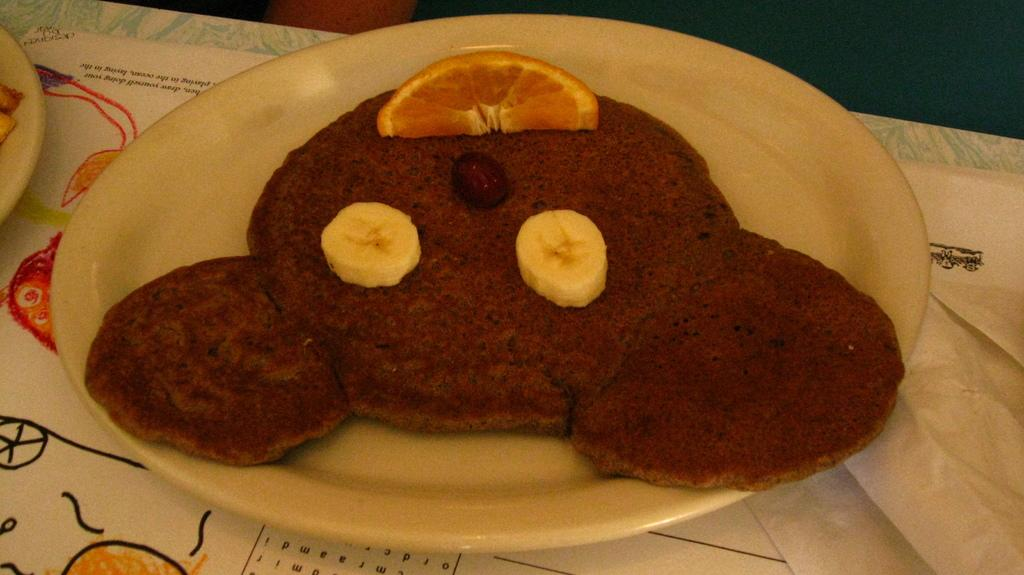What can be seen in the image related to food? There are food items in the image. How are the food items arranged or presented? The food items are on plates. Where are the plates with food items located? The plates with food items are on a table. What type of chalk can be seen on the plates in the image? There is no chalk present on the plates in the image; the plates contain food items. 